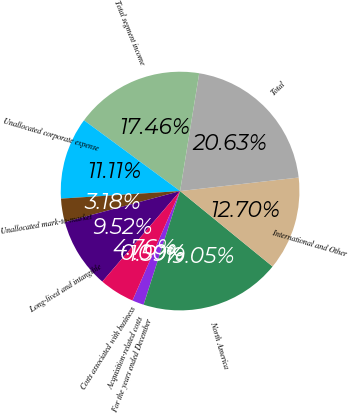Convert chart. <chart><loc_0><loc_0><loc_500><loc_500><pie_chart><fcel>For the years ended December<fcel>North America<fcel>International and Other<fcel>Total<fcel>Total segment income<fcel>Unallocated corporate expense<fcel>Unallocated mark-to-market<fcel>Long-lived and intangible<fcel>Costs associated with business<fcel>Acquisition-related costs<nl><fcel>1.59%<fcel>19.05%<fcel>12.7%<fcel>20.63%<fcel>17.46%<fcel>11.11%<fcel>3.18%<fcel>9.52%<fcel>4.76%<fcel>0.0%<nl></chart> 